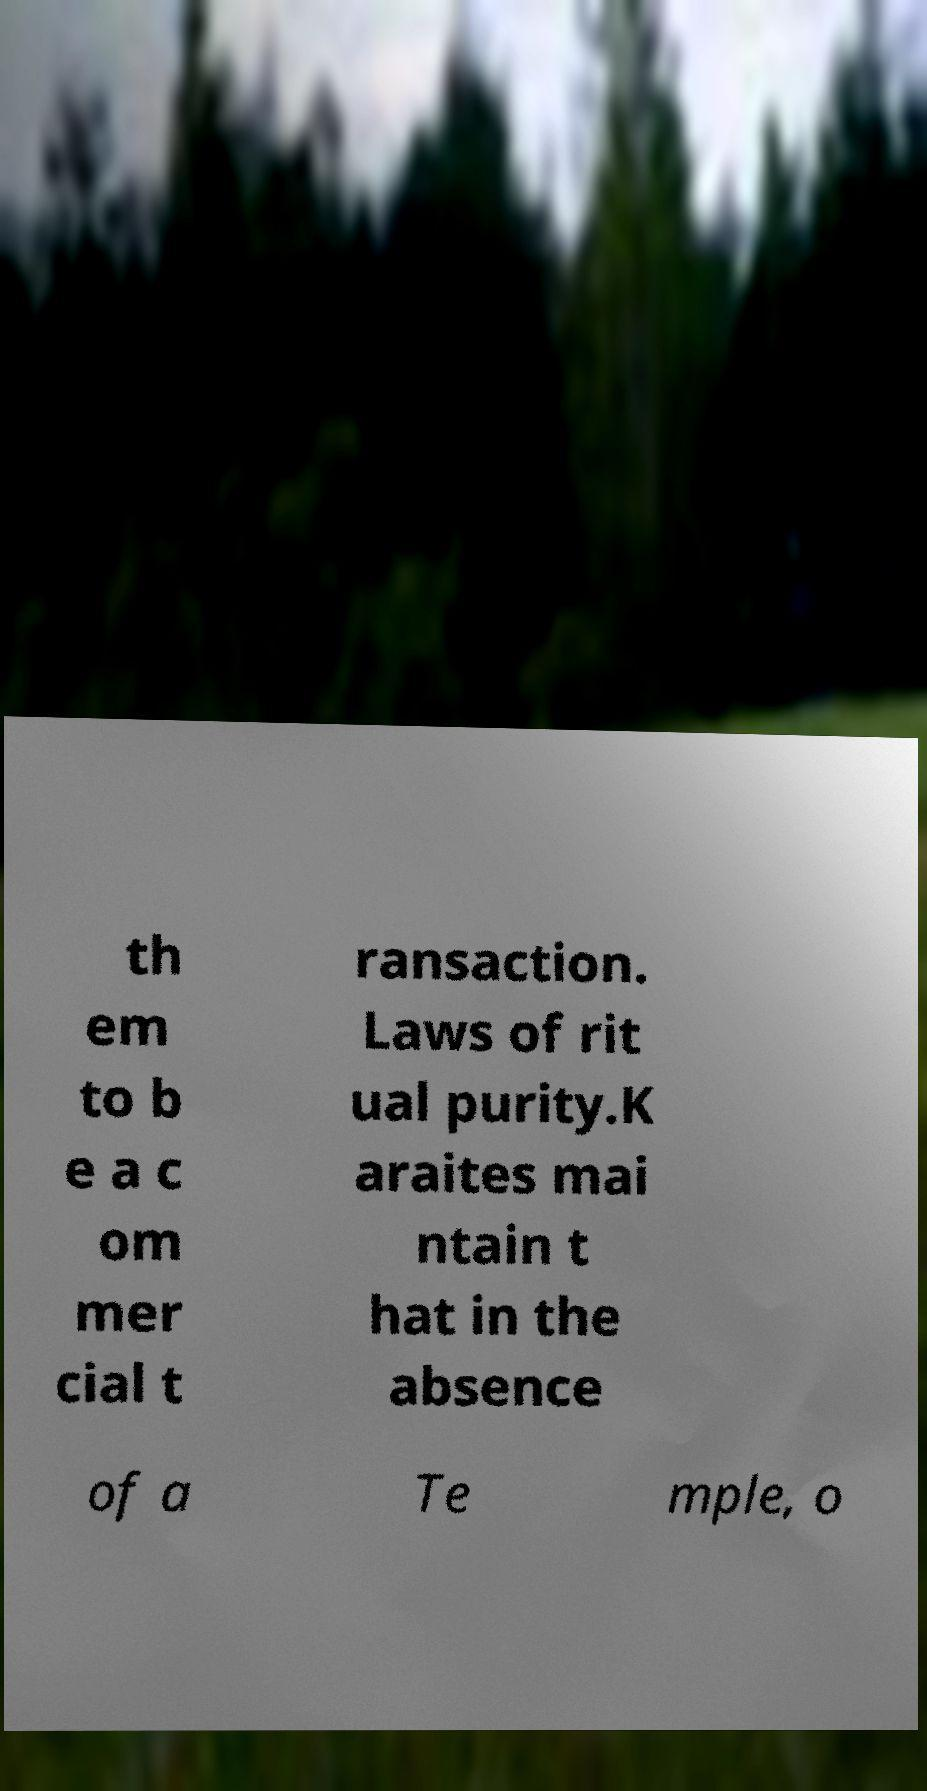I need the written content from this picture converted into text. Can you do that? th em to b e a c om mer cial t ransaction. Laws of rit ual purity.K araites mai ntain t hat in the absence of a Te mple, o 